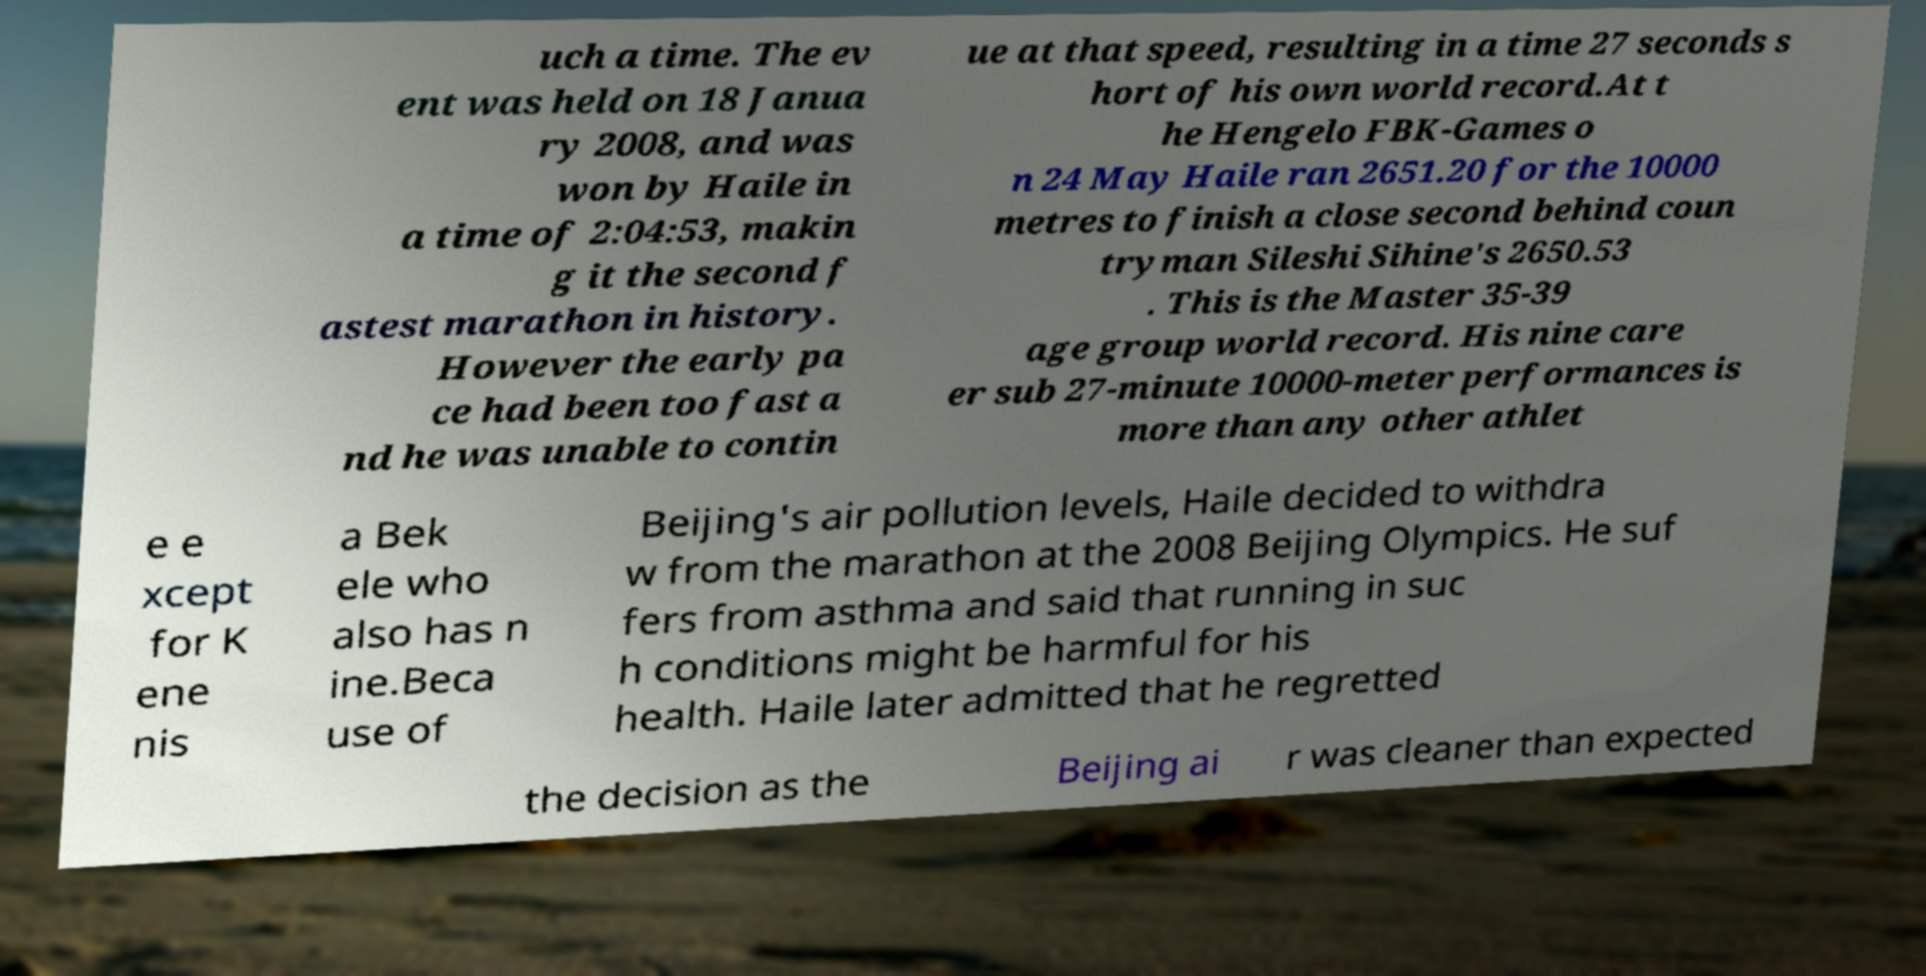For documentation purposes, I need the text within this image transcribed. Could you provide that? uch a time. The ev ent was held on 18 Janua ry 2008, and was won by Haile in a time of 2:04:53, makin g it the second f astest marathon in history. However the early pa ce had been too fast a nd he was unable to contin ue at that speed, resulting in a time 27 seconds s hort of his own world record.At t he Hengelo FBK-Games o n 24 May Haile ran 2651.20 for the 10000 metres to finish a close second behind coun tryman Sileshi Sihine's 2650.53 . This is the Master 35-39 age group world record. His nine care er sub 27-minute 10000-meter performances is more than any other athlet e e xcept for K ene nis a Bek ele who also has n ine.Beca use of Beijing's air pollution levels, Haile decided to withdra w from the marathon at the 2008 Beijing Olympics. He suf fers from asthma and said that running in suc h conditions might be harmful for his health. Haile later admitted that he regretted the decision as the Beijing ai r was cleaner than expected 